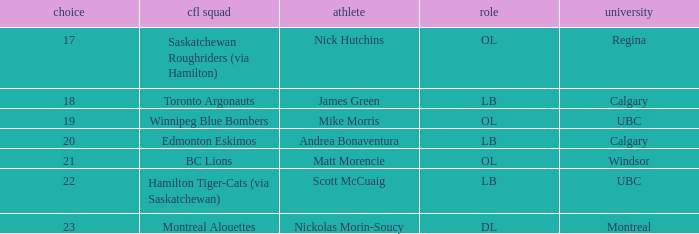What number picks were the players who went to Calgary?  18, 20. 